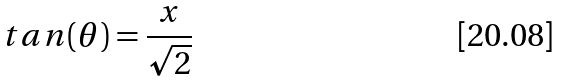Convert formula to latex. <formula><loc_0><loc_0><loc_500><loc_500>t a n ( \theta ) = \frac { x } { \sqrt { 2 } }</formula> 